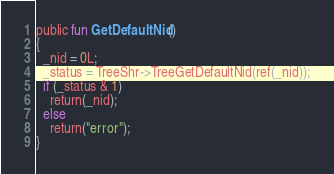<code> <loc_0><loc_0><loc_500><loc_500><_SML_>public fun GetDefaultNid()
{
  _nid = 0L;
  _status = TreeShr->TreeGetDefaultNid(ref(_nid));
  if (_status & 1)
    return(_nid);
  else
    return("error");
}
</code> 